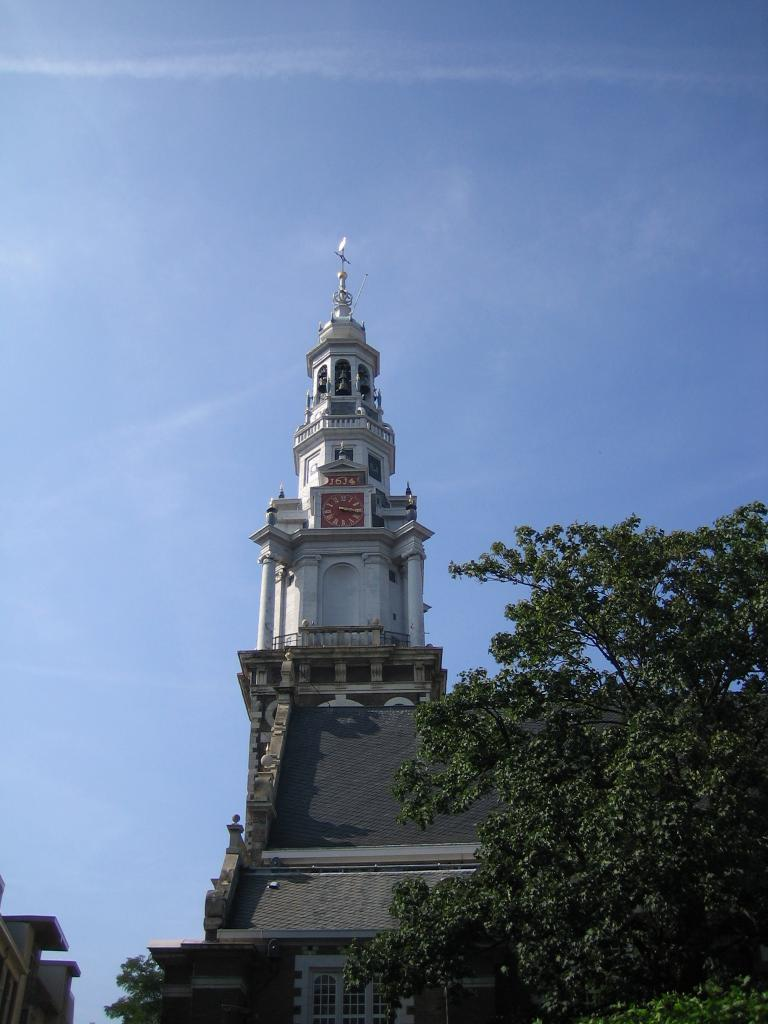What is the main structure in the middle of the image? There is a tower on a building in the middle of the image. What type of vegetation is on the right side of the image? There is a tree on the right side of the image. What color is the sky visible in the background? The blue sky is visible in the background. What type of vest is the doctor wearing in the image? There is no doctor or vest present in the image. How many trees are visible in the image? There is only one tree visible in the image. 